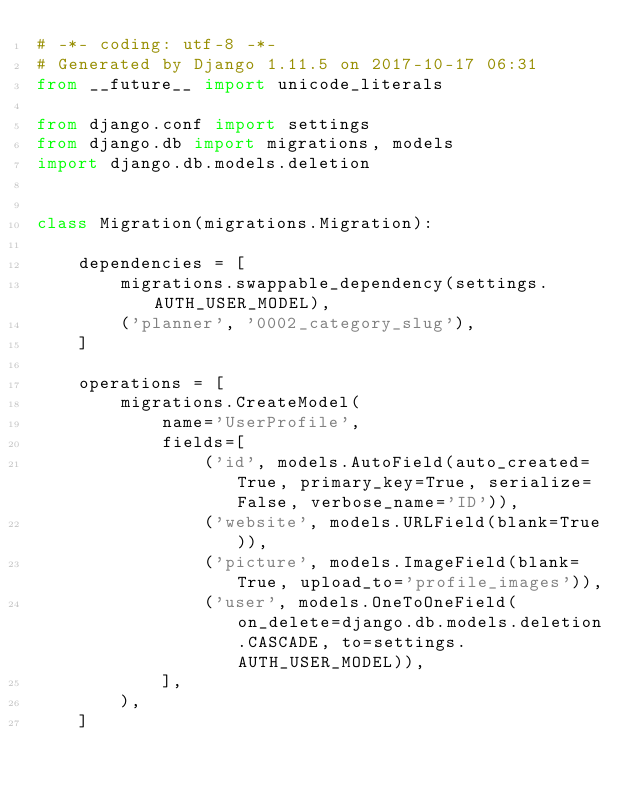<code> <loc_0><loc_0><loc_500><loc_500><_Python_># -*- coding: utf-8 -*-
# Generated by Django 1.11.5 on 2017-10-17 06:31
from __future__ import unicode_literals

from django.conf import settings
from django.db import migrations, models
import django.db.models.deletion


class Migration(migrations.Migration):

    dependencies = [
        migrations.swappable_dependency(settings.AUTH_USER_MODEL),
        ('planner', '0002_category_slug'),
    ]

    operations = [
        migrations.CreateModel(
            name='UserProfile',
            fields=[
                ('id', models.AutoField(auto_created=True, primary_key=True, serialize=False, verbose_name='ID')),
                ('website', models.URLField(blank=True)),
                ('picture', models.ImageField(blank=True, upload_to='profile_images')),
                ('user', models.OneToOneField(on_delete=django.db.models.deletion.CASCADE, to=settings.AUTH_USER_MODEL)),
            ],
        ),
    ]
</code> 